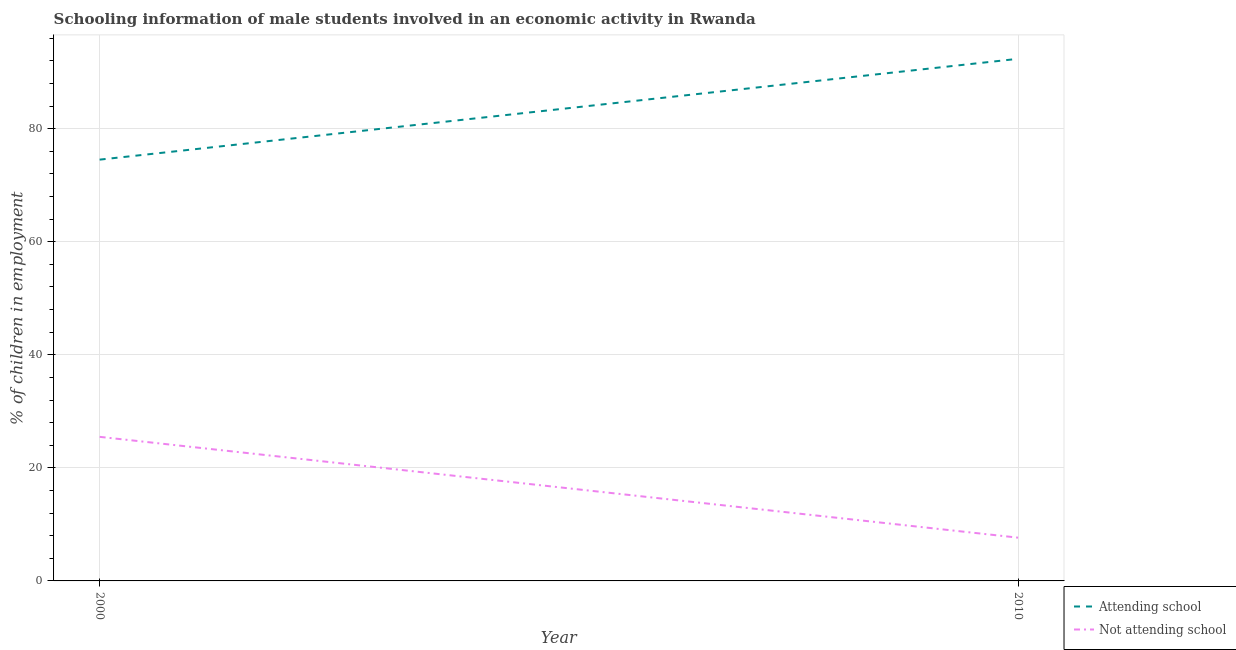Is the number of lines equal to the number of legend labels?
Give a very brief answer. Yes. What is the percentage of employed males who are not attending school in 2000?
Offer a terse response. 25.48. Across all years, what is the maximum percentage of employed males who are attending school?
Provide a succinct answer. 92.35. Across all years, what is the minimum percentage of employed males who are not attending school?
Provide a short and direct response. 7.65. In which year was the percentage of employed males who are attending school maximum?
Your answer should be compact. 2010. In which year was the percentage of employed males who are not attending school minimum?
Offer a terse response. 2010. What is the total percentage of employed males who are attending school in the graph?
Keep it short and to the point. 166.87. What is the difference between the percentage of employed males who are attending school in 2000 and that in 2010?
Your answer should be compact. -17.83. What is the difference between the percentage of employed males who are not attending school in 2010 and the percentage of employed males who are attending school in 2000?
Your response must be concise. -66.87. What is the average percentage of employed males who are attending school per year?
Your answer should be very brief. 83.43. In the year 2010, what is the difference between the percentage of employed males who are attending school and percentage of employed males who are not attending school?
Provide a short and direct response. 84.7. What is the ratio of the percentage of employed males who are attending school in 2000 to that in 2010?
Your answer should be very brief. 0.81. Does the percentage of employed males who are attending school monotonically increase over the years?
Keep it short and to the point. Yes. Is the percentage of employed males who are attending school strictly greater than the percentage of employed males who are not attending school over the years?
Provide a short and direct response. Yes. How many lines are there?
Keep it short and to the point. 2. Are the values on the major ticks of Y-axis written in scientific E-notation?
Keep it short and to the point. No. Does the graph contain any zero values?
Offer a very short reply. No. Does the graph contain grids?
Your response must be concise. Yes. How are the legend labels stacked?
Provide a succinct answer. Vertical. What is the title of the graph?
Offer a terse response. Schooling information of male students involved in an economic activity in Rwanda. What is the label or title of the X-axis?
Keep it short and to the point. Year. What is the label or title of the Y-axis?
Your response must be concise. % of children in employment. What is the % of children in employment of Attending school in 2000?
Provide a short and direct response. 74.52. What is the % of children in employment of Not attending school in 2000?
Your answer should be compact. 25.48. What is the % of children in employment of Attending school in 2010?
Your response must be concise. 92.35. What is the % of children in employment in Not attending school in 2010?
Your response must be concise. 7.65. Across all years, what is the maximum % of children in employment of Attending school?
Your answer should be very brief. 92.35. Across all years, what is the maximum % of children in employment of Not attending school?
Give a very brief answer. 25.48. Across all years, what is the minimum % of children in employment of Attending school?
Offer a very short reply. 74.52. Across all years, what is the minimum % of children in employment in Not attending school?
Your response must be concise. 7.65. What is the total % of children in employment in Attending school in the graph?
Make the answer very short. 166.87. What is the total % of children in employment of Not attending school in the graph?
Provide a short and direct response. 33.13. What is the difference between the % of children in employment in Attending school in 2000 and that in 2010?
Ensure brevity in your answer.  -17.83. What is the difference between the % of children in employment in Not attending school in 2000 and that in 2010?
Offer a terse response. 17.83. What is the difference between the % of children in employment of Attending school in 2000 and the % of children in employment of Not attending school in 2010?
Your answer should be very brief. 66.87. What is the average % of children in employment in Attending school per year?
Provide a succinct answer. 83.43. What is the average % of children in employment in Not attending school per year?
Make the answer very short. 16.57. In the year 2000, what is the difference between the % of children in employment in Attending school and % of children in employment in Not attending school?
Offer a terse response. 49.03. In the year 2010, what is the difference between the % of children in employment in Attending school and % of children in employment in Not attending school?
Your answer should be very brief. 84.7. What is the ratio of the % of children in employment of Attending school in 2000 to that in 2010?
Keep it short and to the point. 0.81. What is the ratio of the % of children in employment of Not attending school in 2000 to that in 2010?
Provide a succinct answer. 3.33. What is the difference between the highest and the second highest % of children in employment in Attending school?
Ensure brevity in your answer.  17.83. What is the difference between the highest and the second highest % of children in employment in Not attending school?
Give a very brief answer. 17.83. What is the difference between the highest and the lowest % of children in employment of Attending school?
Ensure brevity in your answer.  17.83. What is the difference between the highest and the lowest % of children in employment of Not attending school?
Your response must be concise. 17.83. 